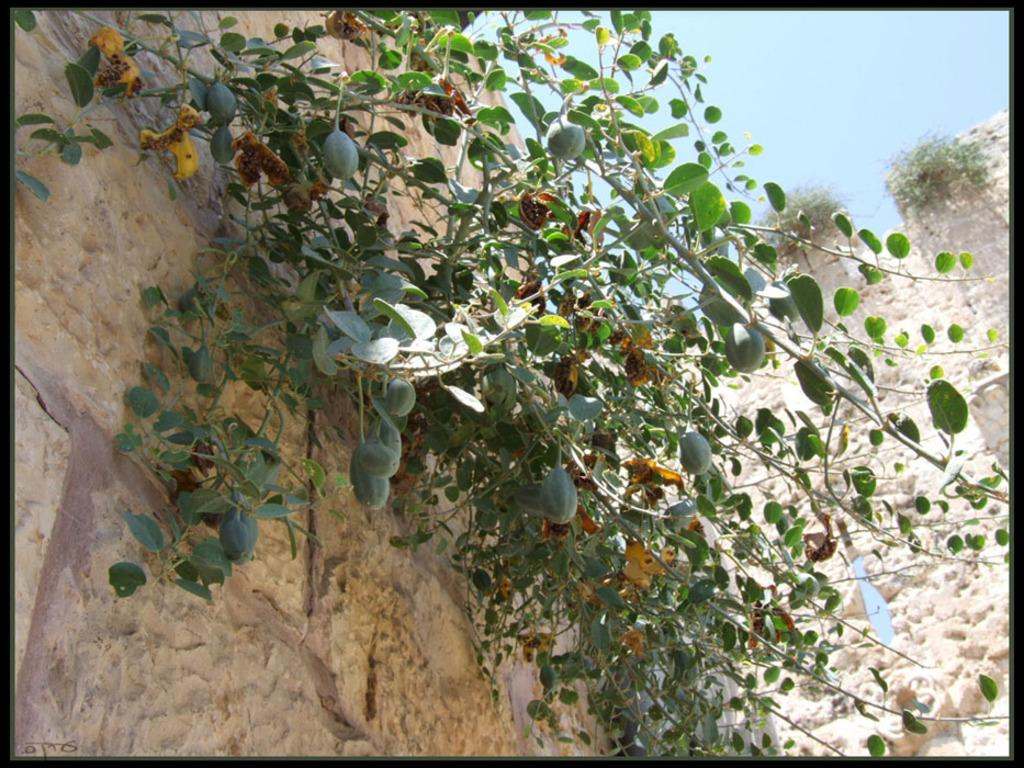What type of plants can be seen in the image? There are creeper plants in the image. What is visible in the background of the image? There is a wall and the sky visible in the background of the image. How many stars can be seen on the wall in the image? There are no stars visible on the wall in the image. Is there a horse present in the image? There is no horse present in the image. 